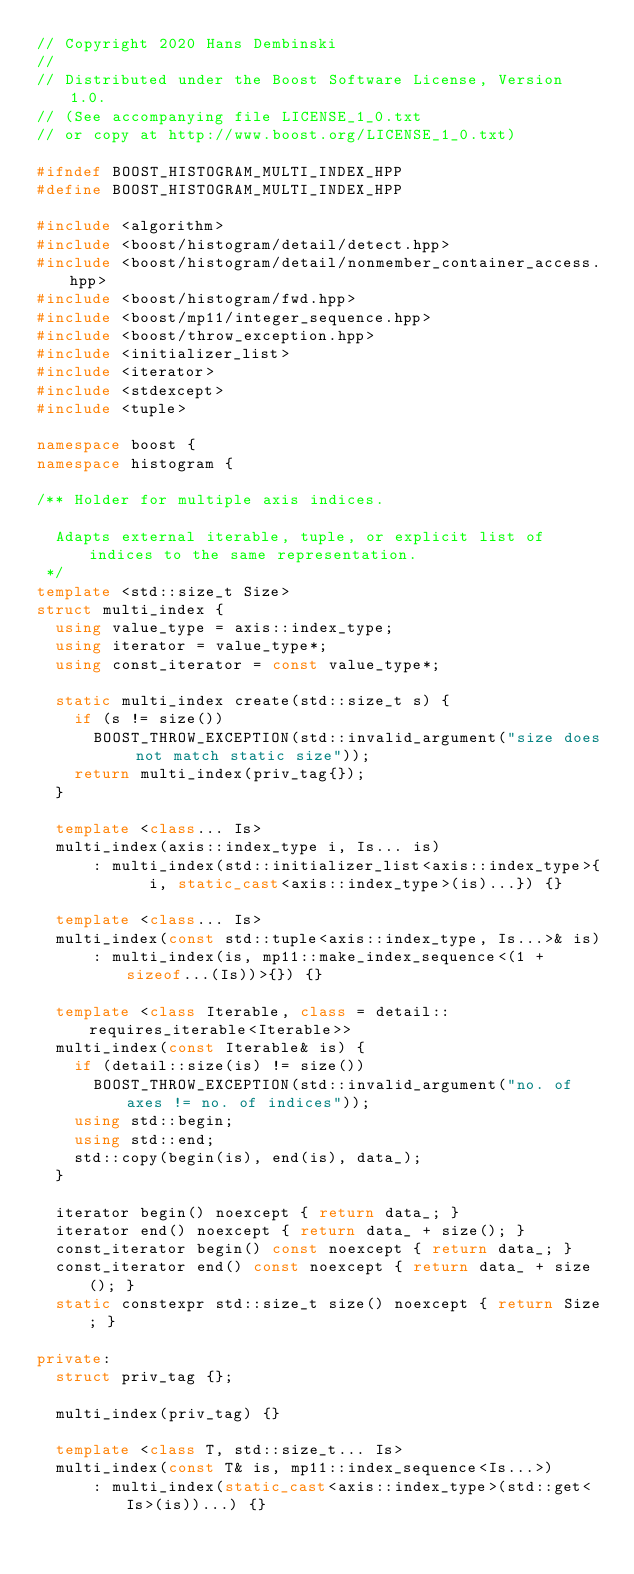<code> <loc_0><loc_0><loc_500><loc_500><_C++_>// Copyright 2020 Hans Dembinski
//
// Distributed under the Boost Software License, Version 1.0.
// (See accompanying file LICENSE_1_0.txt
// or copy at http://www.boost.org/LICENSE_1_0.txt)

#ifndef BOOST_HISTOGRAM_MULTI_INDEX_HPP
#define BOOST_HISTOGRAM_MULTI_INDEX_HPP

#include <algorithm>
#include <boost/histogram/detail/detect.hpp>
#include <boost/histogram/detail/nonmember_container_access.hpp>
#include <boost/histogram/fwd.hpp>
#include <boost/mp11/integer_sequence.hpp>
#include <boost/throw_exception.hpp>
#include <initializer_list>
#include <iterator>
#include <stdexcept>
#include <tuple>

namespace boost {
namespace histogram {

/** Holder for multiple axis indices.

  Adapts external iterable, tuple, or explicit list of indices to the same representation.
 */
template <std::size_t Size>
struct multi_index {
  using value_type = axis::index_type;
  using iterator = value_type*;
  using const_iterator = const value_type*;

  static multi_index create(std::size_t s) {
    if (s != size())
      BOOST_THROW_EXCEPTION(std::invalid_argument("size does not match static size"));
    return multi_index(priv_tag{});
  }

  template <class... Is>
  multi_index(axis::index_type i, Is... is)
      : multi_index(std::initializer_list<axis::index_type>{
            i, static_cast<axis::index_type>(is)...}) {}

  template <class... Is>
  multi_index(const std::tuple<axis::index_type, Is...>& is)
      : multi_index(is, mp11::make_index_sequence<(1 + sizeof...(Is))>{}) {}

  template <class Iterable, class = detail::requires_iterable<Iterable>>
  multi_index(const Iterable& is) {
    if (detail::size(is) != size())
      BOOST_THROW_EXCEPTION(std::invalid_argument("no. of axes != no. of indices"));
    using std::begin;
    using std::end;
    std::copy(begin(is), end(is), data_);
  }

  iterator begin() noexcept { return data_; }
  iterator end() noexcept { return data_ + size(); }
  const_iterator begin() const noexcept { return data_; }
  const_iterator end() const noexcept { return data_ + size(); }
  static constexpr std::size_t size() noexcept { return Size; }

private:
  struct priv_tag {};

  multi_index(priv_tag) {}

  template <class T, std::size_t... Is>
  multi_index(const T& is, mp11::index_sequence<Is...>)
      : multi_index(static_cast<axis::index_type>(std::get<Is>(is))...) {}
</code> 